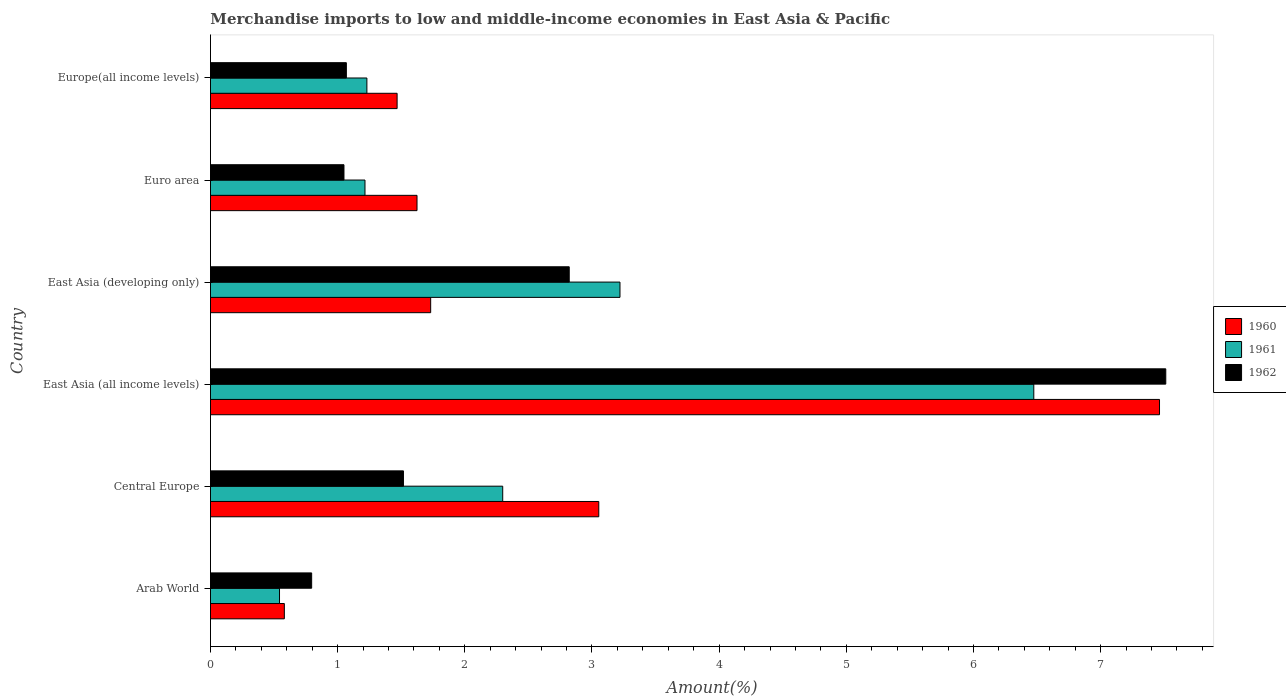How many different coloured bars are there?
Make the answer very short. 3. How many groups of bars are there?
Ensure brevity in your answer.  6. How many bars are there on the 5th tick from the top?
Give a very brief answer. 3. What is the label of the 3rd group of bars from the top?
Keep it short and to the point. East Asia (developing only). In how many cases, is the number of bars for a given country not equal to the number of legend labels?
Keep it short and to the point. 0. What is the percentage of amount earned from merchandise imports in 1962 in Arab World?
Offer a terse response. 0.8. Across all countries, what is the maximum percentage of amount earned from merchandise imports in 1960?
Keep it short and to the point. 7.46. Across all countries, what is the minimum percentage of amount earned from merchandise imports in 1960?
Give a very brief answer. 0.58. In which country was the percentage of amount earned from merchandise imports in 1961 maximum?
Ensure brevity in your answer.  East Asia (all income levels). In which country was the percentage of amount earned from merchandise imports in 1960 minimum?
Provide a succinct answer. Arab World. What is the total percentage of amount earned from merchandise imports in 1960 in the graph?
Your answer should be compact. 15.92. What is the difference between the percentage of amount earned from merchandise imports in 1962 in Central Europe and that in East Asia (developing only)?
Your answer should be compact. -1.3. What is the difference between the percentage of amount earned from merchandise imports in 1962 in Central Europe and the percentage of amount earned from merchandise imports in 1960 in East Asia (developing only)?
Provide a short and direct response. -0.21. What is the average percentage of amount earned from merchandise imports in 1962 per country?
Give a very brief answer. 2.46. What is the difference between the percentage of amount earned from merchandise imports in 1961 and percentage of amount earned from merchandise imports in 1962 in Central Europe?
Offer a terse response. 0.78. What is the ratio of the percentage of amount earned from merchandise imports in 1961 in Arab World to that in East Asia (all income levels)?
Offer a terse response. 0.08. Is the percentage of amount earned from merchandise imports in 1961 in Arab World less than that in East Asia (all income levels)?
Offer a very short reply. Yes. Is the difference between the percentage of amount earned from merchandise imports in 1961 in East Asia (all income levels) and East Asia (developing only) greater than the difference between the percentage of amount earned from merchandise imports in 1962 in East Asia (all income levels) and East Asia (developing only)?
Your response must be concise. No. What is the difference between the highest and the second highest percentage of amount earned from merchandise imports in 1962?
Provide a short and direct response. 4.69. What is the difference between the highest and the lowest percentage of amount earned from merchandise imports in 1961?
Keep it short and to the point. 5.93. In how many countries, is the percentage of amount earned from merchandise imports in 1962 greater than the average percentage of amount earned from merchandise imports in 1962 taken over all countries?
Offer a very short reply. 2. Is it the case that in every country, the sum of the percentage of amount earned from merchandise imports in 1962 and percentage of amount earned from merchandise imports in 1960 is greater than the percentage of amount earned from merchandise imports in 1961?
Provide a short and direct response. Yes. How many countries are there in the graph?
Your response must be concise. 6. What is the difference between two consecutive major ticks on the X-axis?
Offer a terse response. 1. Does the graph contain grids?
Make the answer very short. No. How are the legend labels stacked?
Provide a short and direct response. Vertical. What is the title of the graph?
Ensure brevity in your answer.  Merchandise imports to low and middle-income economies in East Asia & Pacific. Does "1975" appear as one of the legend labels in the graph?
Provide a short and direct response. No. What is the label or title of the X-axis?
Ensure brevity in your answer.  Amount(%). What is the label or title of the Y-axis?
Your answer should be very brief. Country. What is the Amount(%) in 1960 in Arab World?
Make the answer very short. 0.58. What is the Amount(%) in 1961 in Arab World?
Your answer should be compact. 0.54. What is the Amount(%) in 1962 in Arab World?
Your answer should be very brief. 0.8. What is the Amount(%) in 1960 in Central Europe?
Offer a terse response. 3.05. What is the Amount(%) of 1961 in Central Europe?
Your answer should be compact. 2.3. What is the Amount(%) in 1962 in Central Europe?
Make the answer very short. 1.52. What is the Amount(%) in 1960 in East Asia (all income levels)?
Your answer should be very brief. 7.46. What is the Amount(%) of 1961 in East Asia (all income levels)?
Provide a succinct answer. 6.47. What is the Amount(%) in 1962 in East Asia (all income levels)?
Your answer should be compact. 7.51. What is the Amount(%) of 1960 in East Asia (developing only)?
Keep it short and to the point. 1.73. What is the Amount(%) in 1961 in East Asia (developing only)?
Offer a very short reply. 3.22. What is the Amount(%) of 1962 in East Asia (developing only)?
Offer a terse response. 2.82. What is the Amount(%) in 1960 in Euro area?
Ensure brevity in your answer.  1.62. What is the Amount(%) of 1961 in Euro area?
Provide a short and direct response. 1.21. What is the Amount(%) in 1962 in Euro area?
Provide a short and direct response. 1.05. What is the Amount(%) in 1960 in Europe(all income levels)?
Offer a very short reply. 1.47. What is the Amount(%) of 1961 in Europe(all income levels)?
Make the answer very short. 1.23. What is the Amount(%) of 1962 in Europe(all income levels)?
Keep it short and to the point. 1.07. Across all countries, what is the maximum Amount(%) in 1960?
Ensure brevity in your answer.  7.46. Across all countries, what is the maximum Amount(%) of 1961?
Your answer should be compact. 6.47. Across all countries, what is the maximum Amount(%) in 1962?
Keep it short and to the point. 7.51. Across all countries, what is the minimum Amount(%) of 1960?
Keep it short and to the point. 0.58. Across all countries, what is the minimum Amount(%) in 1961?
Your response must be concise. 0.54. Across all countries, what is the minimum Amount(%) in 1962?
Your answer should be very brief. 0.8. What is the total Amount(%) in 1960 in the graph?
Provide a succinct answer. 15.92. What is the total Amount(%) in 1961 in the graph?
Make the answer very short. 14.98. What is the total Amount(%) in 1962 in the graph?
Your response must be concise. 14.76. What is the difference between the Amount(%) in 1960 in Arab World and that in Central Europe?
Your answer should be compact. -2.47. What is the difference between the Amount(%) in 1961 in Arab World and that in Central Europe?
Offer a terse response. -1.76. What is the difference between the Amount(%) of 1962 in Arab World and that in Central Europe?
Make the answer very short. -0.72. What is the difference between the Amount(%) in 1960 in Arab World and that in East Asia (all income levels)?
Provide a succinct answer. -6.88. What is the difference between the Amount(%) in 1961 in Arab World and that in East Asia (all income levels)?
Provide a succinct answer. -5.93. What is the difference between the Amount(%) in 1962 in Arab World and that in East Asia (all income levels)?
Ensure brevity in your answer.  -6.72. What is the difference between the Amount(%) in 1960 in Arab World and that in East Asia (developing only)?
Provide a short and direct response. -1.15. What is the difference between the Amount(%) of 1961 in Arab World and that in East Asia (developing only)?
Ensure brevity in your answer.  -2.68. What is the difference between the Amount(%) in 1962 in Arab World and that in East Asia (developing only)?
Your answer should be very brief. -2.03. What is the difference between the Amount(%) of 1960 in Arab World and that in Euro area?
Provide a succinct answer. -1.04. What is the difference between the Amount(%) of 1961 in Arab World and that in Euro area?
Provide a succinct answer. -0.67. What is the difference between the Amount(%) in 1962 in Arab World and that in Euro area?
Your response must be concise. -0.25. What is the difference between the Amount(%) in 1960 in Arab World and that in Europe(all income levels)?
Offer a very short reply. -0.89. What is the difference between the Amount(%) of 1961 in Arab World and that in Europe(all income levels)?
Your answer should be compact. -0.69. What is the difference between the Amount(%) of 1962 in Arab World and that in Europe(all income levels)?
Your response must be concise. -0.27. What is the difference between the Amount(%) in 1960 in Central Europe and that in East Asia (all income levels)?
Offer a very short reply. -4.41. What is the difference between the Amount(%) of 1961 in Central Europe and that in East Asia (all income levels)?
Your answer should be compact. -4.18. What is the difference between the Amount(%) of 1962 in Central Europe and that in East Asia (all income levels)?
Provide a succinct answer. -5.99. What is the difference between the Amount(%) in 1960 in Central Europe and that in East Asia (developing only)?
Provide a succinct answer. 1.32. What is the difference between the Amount(%) in 1961 in Central Europe and that in East Asia (developing only)?
Your answer should be very brief. -0.92. What is the difference between the Amount(%) in 1962 in Central Europe and that in East Asia (developing only)?
Your answer should be very brief. -1.3. What is the difference between the Amount(%) of 1960 in Central Europe and that in Euro area?
Offer a very short reply. 1.43. What is the difference between the Amount(%) of 1961 in Central Europe and that in Euro area?
Your answer should be very brief. 1.08. What is the difference between the Amount(%) in 1962 in Central Europe and that in Euro area?
Your response must be concise. 0.47. What is the difference between the Amount(%) of 1960 in Central Europe and that in Europe(all income levels)?
Your answer should be very brief. 1.59. What is the difference between the Amount(%) of 1961 in Central Europe and that in Europe(all income levels)?
Provide a succinct answer. 1.07. What is the difference between the Amount(%) of 1962 in Central Europe and that in Europe(all income levels)?
Your answer should be very brief. 0.45. What is the difference between the Amount(%) of 1960 in East Asia (all income levels) and that in East Asia (developing only)?
Your answer should be very brief. 5.73. What is the difference between the Amount(%) of 1961 in East Asia (all income levels) and that in East Asia (developing only)?
Your response must be concise. 3.25. What is the difference between the Amount(%) of 1962 in East Asia (all income levels) and that in East Asia (developing only)?
Offer a very short reply. 4.69. What is the difference between the Amount(%) of 1960 in East Asia (all income levels) and that in Euro area?
Ensure brevity in your answer.  5.84. What is the difference between the Amount(%) of 1961 in East Asia (all income levels) and that in Euro area?
Ensure brevity in your answer.  5.26. What is the difference between the Amount(%) of 1962 in East Asia (all income levels) and that in Euro area?
Make the answer very short. 6.46. What is the difference between the Amount(%) of 1960 in East Asia (all income levels) and that in Europe(all income levels)?
Your response must be concise. 6. What is the difference between the Amount(%) in 1961 in East Asia (all income levels) and that in Europe(all income levels)?
Give a very brief answer. 5.24. What is the difference between the Amount(%) of 1962 in East Asia (all income levels) and that in Europe(all income levels)?
Offer a terse response. 6.44. What is the difference between the Amount(%) of 1960 in East Asia (developing only) and that in Euro area?
Give a very brief answer. 0.11. What is the difference between the Amount(%) of 1961 in East Asia (developing only) and that in Euro area?
Offer a very short reply. 2.01. What is the difference between the Amount(%) of 1962 in East Asia (developing only) and that in Euro area?
Provide a succinct answer. 1.77. What is the difference between the Amount(%) of 1960 in East Asia (developing only) and that in Europe(all income levels)?
Offer a very short reply. 0.26. What is the difference between the Amount(%) in 1961 in East Asia (developing only) and that in Europe(all income levels)?
Your response must be concise. 1.99. What is the difference between the Amount(%) in 1962 in East Asia (developing only) and that in Europe(all income levels)?
Offer a very short reply. 1.75. What is the difference between the Amount(%) of 1960 in Euro area and that in Europe(all income levels)?
Your answer should be very brief. 0.16. What is the difference between the Amount(%) in 1961 in Euro area and that in Europe(all income levels)?
Provide a short and direct response. -0.01. What is the difference between the Amount(%) of 1962 in Euro area and that in Europe(all income levels)?
Your answer should be very brief. -0.02. What is the difference between the Amount(%) of 1960 in Arab World and the Amount(%) of 1961 in Central Europe?
Give a very brief answer. -1.72. What is the difference between the Amount(%) of 1960 in Arab World and the Amount(%) of 1962 in Central Europe?
Provide a short and direct response. -0.94. What is the difference between the Amount(%) in 1961 in Arab World and the Amount(%) in 1962 in Central Europe?
Offer a very short reply. -0.97. What is the difference between the Amount(%) in 1960 in Arab World and the Amount(%) in 1961 in East Asia (all income levels)?
Your answer should be very brief. -5.89. What is the difference between the Amount(%) of 1960 in Arab World and the Amount(%) of 1962 in East Asia (all income levels)?
Your answer should be very brief. -6.93. What is the difference between the Amount(%) in 1961 in Arab World and the Amount(%) in 1962 in East Asia (all income levels)?
Offer a very short reply. -6.97. What is the difference between the Amount(%) of 1960 in Arab World and the Amount(%) of 1961 in East Asia (developing only)?
Provide a short and direct response. -2.64. What is the difference between the Amount(%) of 1960 in Arab World and the Amount(%) of 1962 in East Asia (developing only)?
Ensure brevity in your answer.  -2.24. What is the difference between the Amount(%) in 1961 in Arab World and the Amount(%) in 1962 in East Asia (developing only)?
Give a very brief answer. -2.28. What is the difference between the Amount(%) of 1960 in Arab World and the Amount(%) of 1961 in Euro area?
Your answer should be compact. -0.63. What is the difference between the Amount(%) of 1960 in Arab World and the Amount(%) of 1962 in Euro area?
Your response must be concise. -0.47. What is the difference between the Amount(%) of 1961 in Arab World and the Amount(%) of 1962 in Euro area?
Keep it short and to the point. -0.51. What is the difference between the Amount(%) of 1960 in Arab World and the Amount(%) of 1961 in Europe(all income levels)?
Make the answer very short. -0.65. What is the difference between the Amount(%) of 1960 in Arab World and the Amount(%) of 1962 in Europe(all income levels)?
Make the answer very short. -0.49. What is the difference between the Amount(%) of 1961 in Arab World and the Amount(%) of 1962 in Europe(all income levels)?
Offer a terse response. -0.53. What is the difference between the Amount(%) in 1960 in Central Europe and the Amount(%) in 1961 in East Asia (all income levels)?
Provide a short and direct response. -3.42. What is the difference between the Amount(%) of 1960 in Central Europe and the Amount(%) of 1962 in East Asia (all income levels)?
Provide a succinct answer. -4.46. What is the difference between the Amount(%) of 1961 in Central Europe and the Amount(%) of 1962 in East Asia (all income levels)?
Provide a short and direct response. -5.21. What is the difference between the Amount(%) of 1960 in Central Europe and the Amount(%) of 1961 in East Asia (developing only)?
Keep it short and to the point. -0.17. What is the difference between the Amount(%) of 1960 in Central Europe and the Amount(%) of 1962 in East Asia (developing only)?
Your response must be concise. 0.23. What is the difference between the Amount(%) in 1961 in Central Europe and the Amount(%) in 1962 in East Asia (developing only)?
Your answer should be very brief. -0.52. What is the difference between the Amount(%) of 1960 in Central Europe and the Amount(%) of 1961 in Euro area?
Your response must be concise. 1.84. What is the difference between the Amount(%) of 1960 in Central Europe and the Amount(%) of 1962 in Euro area?
Keep it short and to the point. 2. What is the difference between the Amount(%) in 1961 in Central Europe and the Amount(%) in 1962 in Euro area?
Give a very brief answer. 1.25. What is the difference between the Amount(%) of 1960 in Central Europe and the Amount(%) of 1961 in Europe(all income levels)?
Make the answer very short. 1.82. What is the difference between the Amount(%) of 1960 in Central Europe and the Amount(%) of 1962 in Europe(all income levels)?
Make the answer very short. 1.98. What is the difference between the Amount(%) of 1961 in Central Europe and the Amount(%) of 1962 in Europe(all income levels)?
Provide a short and direct response. 1.23. What is the difference between the Amount(%) in 1960 in East Asia (all income levels) and the Amount(%) in 1961 in East Asia (developing only)?
Keep it short and to the point. 4.24. What is the difference between the Amount(%) in 1960 in East Asia (all income levels) and the Amount(%) in 1962 in East Asia (developing only)?
Offer a terse response. 4.64. What is the difference between the Amount(%) of 1961 in East Asia (all income levels) and the Amount(%) of 1962 in East Asia (developing only)?
Keep it short and to the point. 3.65. What is the difference between the Amount(%) of 1960 in East Asia (all income levels) and the Amount(%) of 1961 in Euro area?
Provide a succinct answer. 6.25. What is the difference between the Amount(%) of 1960 in East Asia (all income levels) and the Amount(%) of 1962 in Euro area?
Offer a very short reply. 6.41. What is the difference between the Amount(%) in 1961 in East Asia (all income levels) and the Amount(%) in 1962 in Euro area?
Your response must be concise. 5.42. What is the difference between the Amount(%) of 1960 in East Asia (all income levels) and the Amount(%) of 1961 in Europe(all income levels)?
Ensure brevity in your answer.  6.23. What is the difference between the Amount(%) of 1960 in East Asia (all income levels) and the Amount(%) of 1962 in Europe(all income levels)?
Offer a terse response. 6.39. What is the difference between the Amount(%) of 1961 in East Asia (all income levels) and the Amount(%) of 1962 in Europe(all income levels)?
Ensure brevity in your answer.  5.41. What is the difference between the Amount(%) of 1960 in East Asia (developing only) and the Amount(%) of 1961 in Euro area?
Your answer should be compact. 0.52. What is the difference between the Amount(%) of 1960 in East Asia (developing only) and the Amount(%) of 1962 in Euro area?
Your answer should be compact. 0.68. What is the difference between the Amount(%) of 1961 in East Asia (developing only) and the Amount(%) of 1962 in Euro area?
Offer a very short reply. 2.17. What is the difference between the Amount(%) of 1960 in East Asia (developing only) and the Amount(%) of 1961 in Europe(all income levels)?
Provide a short and direct response. 0.5. What is the difference between the Amount(%) in 1960 in East Asia (developing only) and the Amount(%) in 1962 in Europe(all income levels)?
Offer a very short reply. 0.66. What is the difference between the Amount(%) of 1961 in East Asia (developing only) and the Amount(%) of 1962 in Europe(all income levels)?
Make the answer very short. 2.15. What is the difference between the Amount(%) in 1960 in Euro area and the Amount(%) in 1961 in Europe(all income levels)?
Provide a succinct answer. 0.39. What is the difference between the Amount(%) in 1960 in Euro area and the Amount(%) in 1962 in Europe(all income levels)?
Make the answer very short. 0.56. What is the difference between the Amount(%) of 1961 in Euro area and the Amount(%) of 1962 in Europe(all income levels)?
Keep it short and to the point. 0.15. What is the average Amount(%) in 1960 per country?
Your answer should be very brief. 2.65. What is the average Amount(%) of 1961 per country?
Your answer should be very brief. 2.5. What is the average Amount(%) of 1962 per country?
Provide a succinct answer. 2.46. What is the difference between the Amount(%) of 1960 and Amount(%) of 1961 in Arab World?
Your response must be concise. 0.04. What is the difference between the Amount(%) of 1960 and Amount(%) of 1962 in Arab World?
Give a very brief answer. -0.21. What is the difference between the Amount(%) of 1961 and Amount(%) of 1962 in Arab World?
Keep it short and to the point. -0.25. What is the difference between the Amount(%) of 1960 and Amount(%) of 1961 in Central Europe?
Keep it short and to the point. 0.76. What is the difference between the Amount(%) in 1960 and Amount(%) in 1962 in Central Europe?
Your answer should be compact. 1.54. What is the difference between the Amount(%) of 1961 and Amount(%) of 1962 in Central Europe?
Your answer should be compact. 0.78. What is the difference between the Amount(%) in 1960 and Amount(%) in 1962 in East Asia (all income levels)?
Make the answer very short. -0.05. What is the difference between the Amount(%) of 1961 and Amount(%) of 1962 in East Asia (all income levels)?
Ensure brevity in your answer.  -1.04. What is the difference between the Amount(%) of 1960 and Amount(%) of 1961 in East Asia (developing only)?
Provide a short and direct response. -1.49. What is the difference between the Amount(%) of 1960 and Amount(%) of 1962 in East Asia (developing only)?
Your response must be concise. -1.09. What is the difference between the Amount(%) of 1961 and Amount(%) of 1962 in East Asia (developing only)?
Provide a succinct answer. 0.4. What is the difference between the Amount(%) in 1960 and Amount(%) in 1961 in Euro area?
Keep it short and to the point. 0.41. What is the difference between the Amount(%) in 1960 and Amount(%) in 1962 in Euro area?
Your answer should be compact. 0.57. What is the difference between the Amount(%) of 1961 and Amount(%) of 1962 in Euro area?
Your answer should be very brief. 0.17. What is the difference between the Amount(%) in 1960 and Amount(%) in 1961 in Europe(all income levels)?
Keep it short and to the point. 0.24. What is the difference between the Amount(%) in 1960 and Amount(%) in 1962 in Europe(all income levels)?
Your response must be concise. 0.4. What is the difference between the Amount(%) in 1961 and Amount(%) in 1962 in Europe(all income levels)?
Your answer should be very brief. 0.16. What is the ratio of the Amount(%) in 1960 in Arab World to that in Central Europe?
Keep it short and to the point. 0.19. What is the ratio of the Amount(%) in 1961 in Arab World to that in Central Europe?
Your answer should be compact. 0.24. What is the ratio of the Amount(%) of 1962 in Arab World to that in Central Europe?
Give a very brief answer. 0.52. What is the ratio of the Amount(%) in 1960 in Arab World to that in East Asia (all income levels)?
Ensure brevity in your answer.  0.08. What is the ratio of the Amount(%) in 1961 in Arab World to that in East Asia (all income levels)?
Provide a short and direct response. 0.08. What is the ratio of the Amount(%) of 1962 in Arab World to that in East Asia (all income levels)?
Offer a terse response. 0.11. What is the ratio of the Amount(%) in 1960 in Arab World to that in East Asia (developing only)?
Your answer should be compact. 0.34. What is the ratio of the Amount(%) of 1961 in Arab World to that in East Asia (developing only)?
Give a very brief answer. 0.17. What is the ratio of the Amount(%) of 1962 in Arab World to that in East Asia (developing only)?
Provide a short and direct response. 0.28. What is the ratio of the Amount(%) of 1960 in Arab World to that in Euro area?
Keep it short and to the point. 0.36. What is the ratio of the Amount(%) of 1961 in Arab World to that in Euro area?
Your answer should be compact. 0.45. What is the ratio of the Amount(%) in 1962 in Arab World to that in Euro area?
Provide a short and direct response. 0.76. What is the ratio of the Amount(%) in 1960 in Arab World to that in Europe(all income levels)?
Provide a short and direct response. 0.4. What is the ratio of the Amount(%) of 1961 in Arab World to that in Europe(all income levels)?
Your response must be concise. 0.44. What is the ratio of the Amount(%) of 1962 in Arab World to that in Europe(all income levels)?
Your answer should be very brief. 0.74. What is the ratio of the Amount(%) of 1960 in Central Europe to that in East Asia (all income levels)?
Provide a short and direct response. 0.41. What is the ratio of the Amount(%) in 1961 in Central Europe to that in East Asia (all income levels)?
Offer a very short reply. 0.35. What is the ratio of the Amount(%) of 1962 in Central Europe to that in East Asia (all income levels)?
Provide a succinct answer. 0.2. What is the ratio of the Amount(%) in 1960 in Central Europe to that in East Asia (developing only)?
Give a very brief answer. 1.76. What is the ratio of the Amount(%) in 1961 in Central Europe to that in East Asia (developing only)?
Your response must be concise. 0.71. What is the ratio of the Amount(%) of 1962 in Central Europe to that in East Asia (developing only)?
Provide a short and direct response. 0.54. What is the ratio of the Amount(%) in 1960 in Central Europe to that in Euro area?
Give a very brief answer. 1.88. What is the ratio of the Amount(%) of 1961 in Central Europe to that in Euro area?
Your response must be concise. 1.89. What is the ratio of the Amount(%) in 1962 in Central Europe to that in Euro area?
Keep it short and to the point. 1.45. What is the ratio of the Amount(%) of 1960 in Central Europe to that in Europe(all income levels)?
Make the answer very short. 2.08. What is the ratio of the Amount(%) of 1961 in Central Europe to that in Europe(all income levels)?
Offer a terse response. 1.87. What is the ratio of the Amount(%) in 1962 in Central Europe to that in Europe(all income levels)?
Offer a very short reply. 1.42. What is the ratio of the Amount(%) in 1960 in East Asia (all income levels) to that in East Asia (developing only)?
Your answer should be compact. 4.31. What is the ratio of the Amount(%) of 1961 in East Asia (all income levels) to that in East Asia (developing only)?
Provide a short and direct response. 2.01. What is the ratio of the Amount(%) of 1962 in East Asia (all income levels) to that in East Asia (developing only)?
Offer a very short reply. 2.66. What is the ratio of the Amount(%) in 1960 in East Asia (all income levels) to that in Euro area?
Provide a succinct answer. 4.59. What is the ratio of the Amount(%) of 1961 in East Asia (all income levels) to that in Euro area?
Offer a very short reply. 5.33. What is the ratio of the Amount(%) of 1962 in East Asia (all income levels) to that in Euro area?
Ensure brevity in your answer.  7.16. What is the ratio of the Amount(%) of 1960 in East Asia (all income levels) to that in Europe(all income levels)?
Keep it short and to the point. 5.09. What is the ratio of the Amount(%) of 1961 in East Asia (all income levels) to that in Europe(all income levels)?
Make the answer very short. 5.26. What is the ratio of the Amount(%) in 1962 in East Asia (all income levels) to that in Europe(all income levels)?
Your response must be concise. 7.03. What is the ratio of the Amount(%) of 1960 in East Asia (developing only) to that in Euro area?
Keep it short and to the point. 1.07. What is the ratio of the Amount(%) of 1961 in East Asia (developing only) to that in Euro area?
Your answer should be compact. 2.65. What is the ratio of the Amount(%) of 1962 in East Asia (developing only) to that in Euro area?
Give a very brief answer. 2.69. What is the ratio of the Amount(%) in 1960 in East Asia (developing only) to that in Europe(all income levels)?
Your answer should be compact. 1.18. What is the ratio of the Amount(%) of 1961 in East Asia (developing only) to that in Europe(all income levels)?
Offer a very short reply. 2.62. What is the ratio of the Amount(%) in 1962 in East Asia (developing only) to that in Europe(all income levels)?
Give a very brief answer. 2.64. What is the ratio of the Amount(%) in 1960 in Euro area to that in Europe(all income levels)?
Make the answer very short. 1.11. What is the ratio of the Amount(%) in 1962 in Euro area to that in Europe(all income levels)?
Make the answer very short. 0.98. What is the difference between the highest and the second highest Amount(%) of 1960?
Offer a very short reply. 4.41. What is the difference between the highest and the second highest Amount(%) in 1961?
Your answer should be compact. 3.25. What is the difference between the highest and the second highest Amount(%) of 1962?
Provide a short and direct response. 4.69. What is the difference between the highest and the lowest Amount(%) of 1960?
Provide a short and direct response. 6.88. What is the difference between the highest and the lowest Amount(%) of 1961?
Provide a succinct answer. 5.93. What is the difference between the highest and the lowest Amount(%) of 1962?
Give a very brief answer. 6.72. 